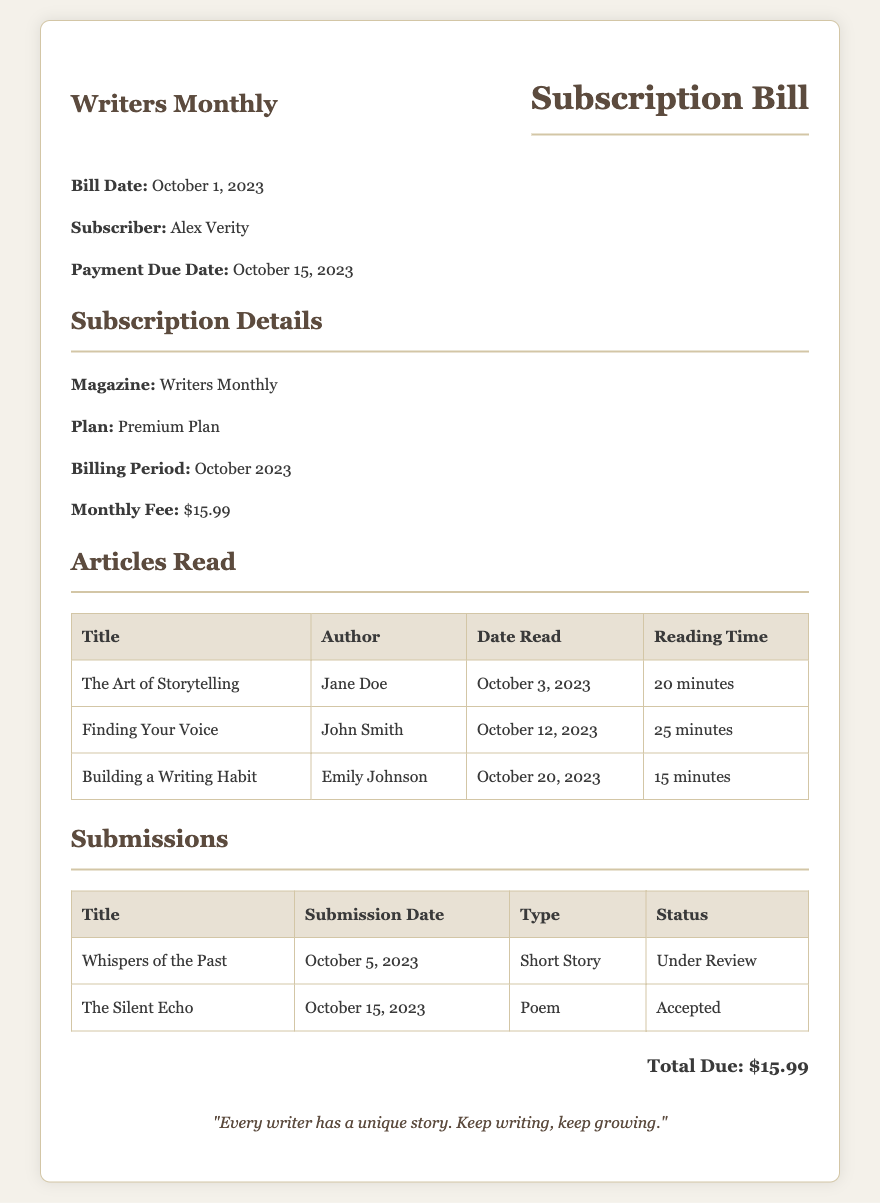What is the subscriber's name? The subscriber's name is provided in the bill details section.
Answer: Alex Verity What is the payment due date? The payment due date is mentioned close to the subscriber's information.
Answer: October 15, 2023 What is the monthly fee for the subscription? The fee is listed in the subscription details section.
Answer: $15.99 How many articles were read in October? The number of articles read can be counted from the articles table.
Answer: 3 What is the title of the first article read? The title of the articles read is found in the first row of the articles table.
Answer: The Art of Storytelling What is the status of the second submission? The status of submissions is shown in the submissions table.
Answer: Accepted What type of content was submitted on October 5, 2023? The type of content is detailed in the submissions table.
Answer: Short Story What reading time is listed for "Finding Your Voice"? The reading time information is provided in the articles table.
Answer: 25 minutes What magazine is specified in the subscription details? The magazine name is clearly stated in the subscription details section.
Answer: Writers Monthly 